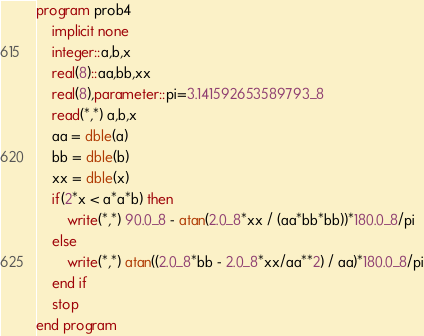<code> <loc_0><loc_0><loc_500><loc_500><_FORTRAN_>program prob4
    implicit none
    integer::a,b,x
    real(8)::aa,bb,xx
    real(8),parameter::pi=3.141592653589793_8
    read(*,*) a,b,x
    aa = dble(a)
    bb = dble(b)
    xx = dble(x)
    if(2*x < a*a*b) then
        write(*,*) 90.0_8 - atan(2.0_8*xx / (aa*bb*bb))*180.0_8/pi
    else
        write(*,*) atan((2.0_8*bb - 2.0_8*xx/aa**2) / aa)*180.0_8/pi
    end if
    stop
end program</code> 